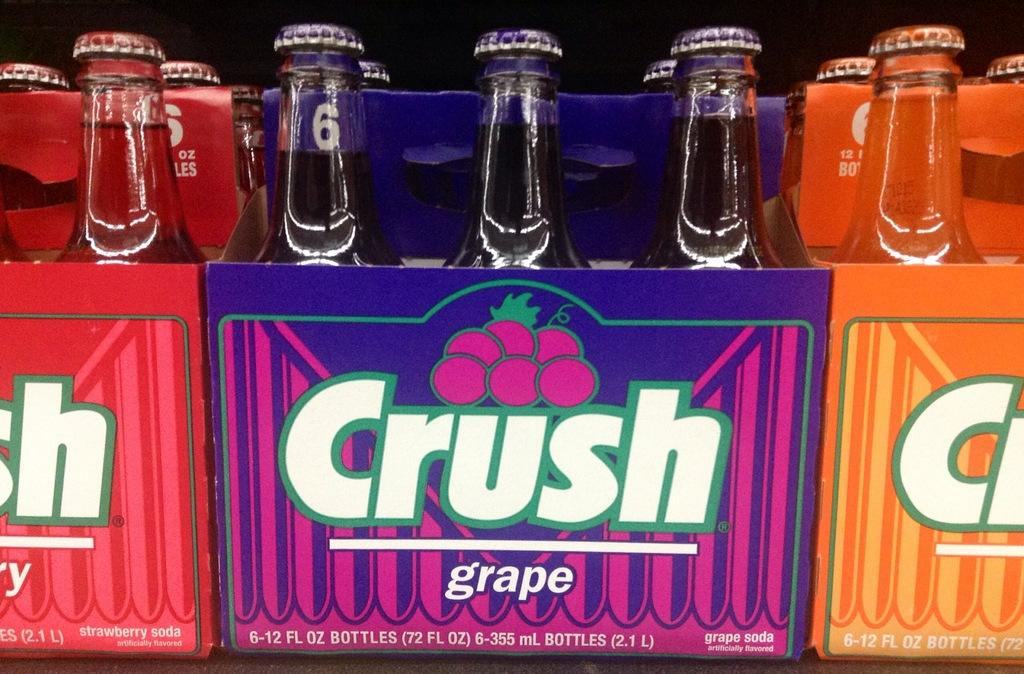<image>
Share a concise interpretation of the image provided. packs of crush soda next to each other with the middle flavor being grape 